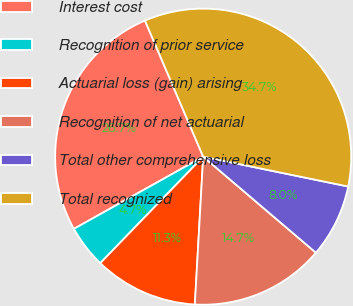Convert chart. <chart><loc_0><loc_0><loc_500><loc_500><pie_chart><fcel>Interest cost<fcel>Recognition of prior service<fcel>Actuarial loss (gain) arising<fcel>Recognition of net actuarial<fcel>Total other comprehensive loss<fcel>Total recognized<nl><fcel>26.67%<fcel>4.67%<fcel>11.33%<fcel>14.67%<fcel>8.0%<fcel>34.67%<nl></chart> 